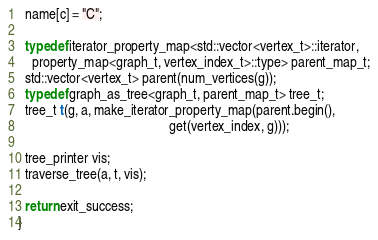<code> <loc_0><loc_0><loc_500><loc_500><_C++_>  name[c] = "C";

  typedef iterator_property_map<std::vector<vertex_t>::iterator,
    property_map<graph_t, vertex_index_t>::type> parent_map_t;
  std::vector<vertex_t> parent(num_vertices(g));
  typedef graph_as_tree<graph_t, parent_map_t> tree_t;
  tree_t t(g, a, make_iterator_property_map(parent.begin(), 
                                            get(vertex_index, g)));

  tree_printer vis;
  traverse_tree(a, t, vis);
  
  return exit_success;
}
</code> 